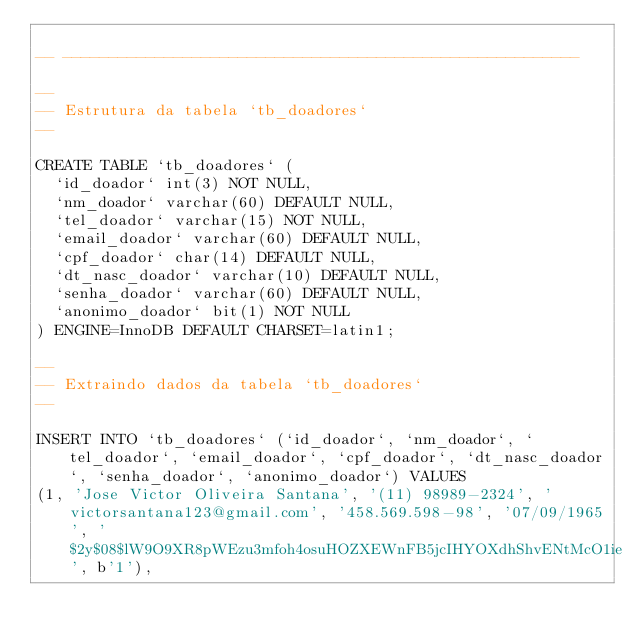<code> <loc_0><loc_0><loc_500><loc_500><_SQL_>
-- --------------------------------------------------------

--
-- Estrutura da tabela `tb_doadores`
--

CREATE TABLE `tb_doadores` (
  `id_doador` int(3) NOT NULL,
  `nm_doador` varchar(60) DEFAULT NULL,
  `tel_doador` varchar(15) NOT NULL,
  `email_doador` varchar(60) DEFAULT NULL,
  `cpf_doador` char(14) DEFAULT NULL,
  `dt_nasc_doador` varchar(10) DEFAULT NULL,
  `senha_doador` varchar(60) DEFAULT NULL,
  `anonimo_doador` bit(1) NOT NULL
) ENGINE=InnoDB DEFAULT CHARSET=latin1;

--
-- Extraindo dados da tabela `tb_doadores`
--

INSERT INTO `tb_doadores` (`id_doador`, `nm_doador`, `tel_doador`, `email_doador`, `cpf_doador`, `dt_nasc_doador`, `senha_doador`, `anonimo_doador`) VALUES
(1, 'Jose Victor Oliveira Santana', '(11) 98989-2324', 'victorsantana123@gmail.com', '458.569.598-98', '07/09/1965', '$2y$08$lW9O9XR8pWEzu3mfoh4osuHOZXEWnFB5jcIHYOXdhShvENtMcO1ie', b'1'),</code> 